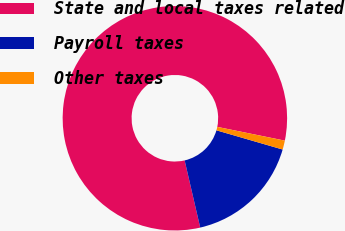Convert chart to OTSL. <chart><loc_0><loc_0><loc_500><loc_500><pie_chart><fcel>State and local taxes related<fcel>Payroll taxes<fcel>Other taxes<nl><fcel>81.82%<fcel>16.88%<fcel>1.3%<nl></chart> 